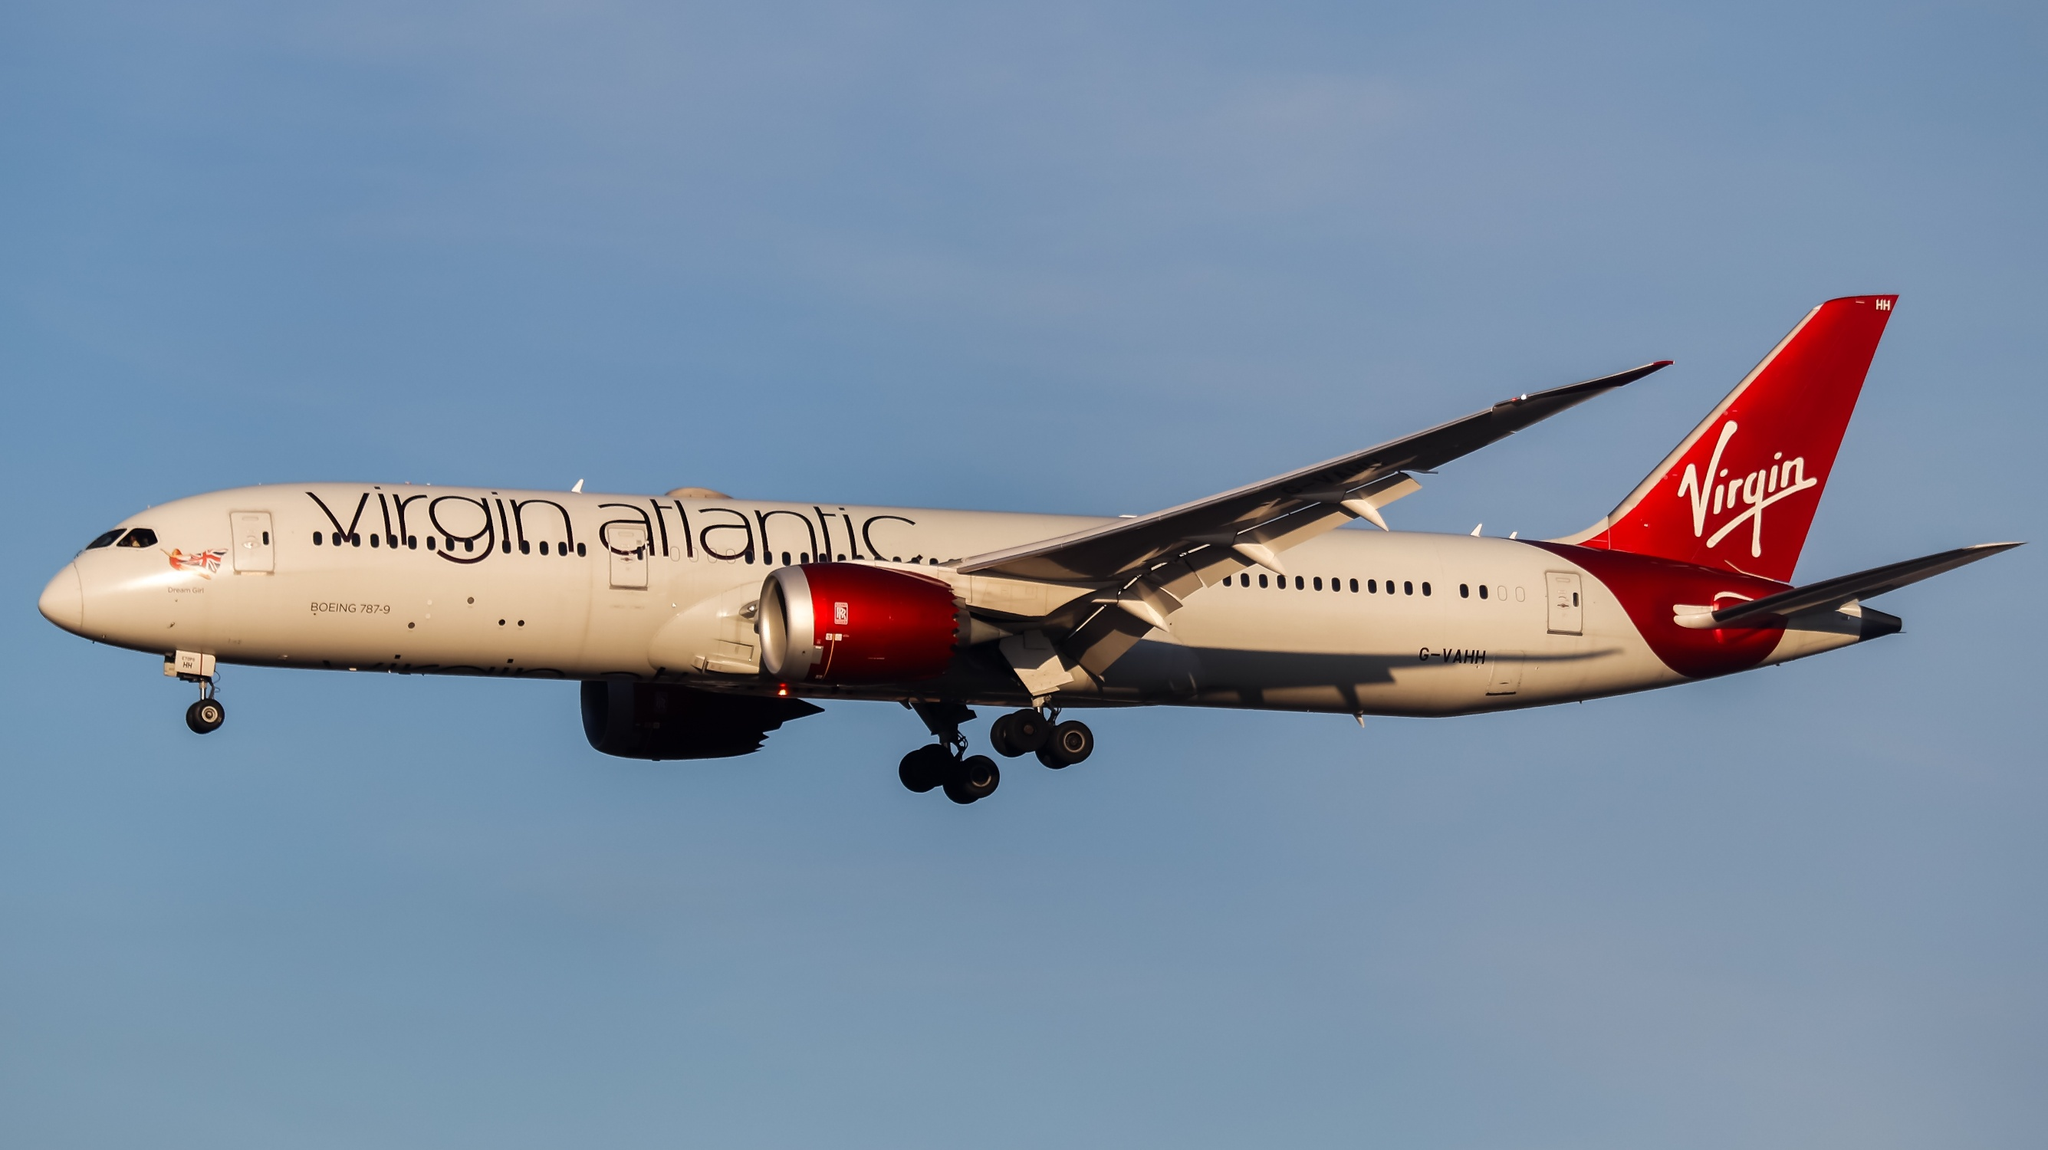Can you describe the design and branding elements on this airplane? The Virgin Atlantic Boeing 787-9 Dreamliner in the image exemplifies a sophisticated and vibrant design. The fuselage is predominantly painted white, providing a clean and modern look. The most striking design element is the bold 'Virgin Atlantic' text in black, stretched across the body of the plane, ensuring high visibility and brand recognition. The tail is a bright red, a signature color of the airline, emblazoned with the 'Virgin' logo in white cursive lettering. The engines are also painted red, creating a cohesive and dynamic look that exudes luxury and modernity. Together, these elements form a visually appealing and instantly recognizable brand identity. 